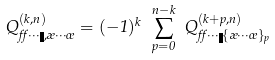<formula> <loc_0><loc_0><loc_500><loc_500>Q _ { \alpha \cdots \eta , \rho \cdots \sigma } ^ { ( k , n ) } = ( - 1 ) ^ { k } \ \sum _ { p = 0 } ^ { n - k } \ Q _ { \alpha \cdots \eta \{ \rho \cdots \sigma \} _ { p } } ^ { ( k + p , n ) }</formula> 